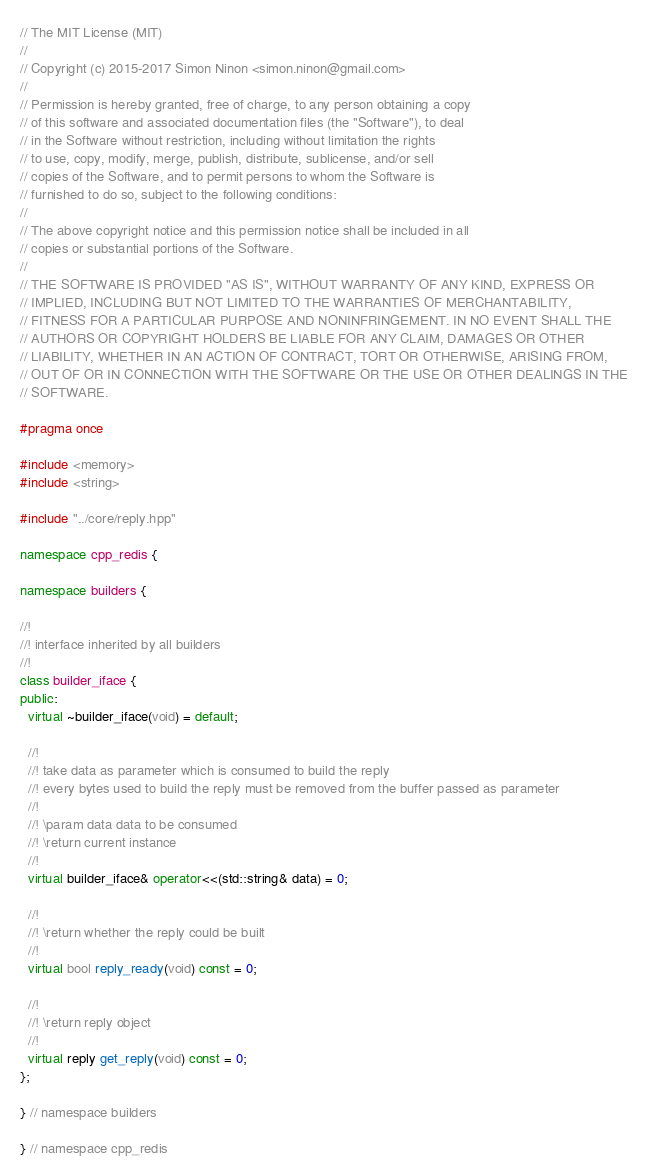Convert code to text. <code><loc_0><loc_0><loc_500><loc_500><_C++_>// The MIT License (MIT)
//
// Copyright (c) 2015-2017 Simon Ninon <simon.ninon@gmail.com>
//
// Permission is hereby granted, free of charge, to any person obtaining a copy
// of this software and associated documentation files (the "Software"), to deal
// in the Software without restriction, including without limitation the rights
// to use, copy, modify, merge, publish, distribute, sublicense, and/or sell
// copies of the Software, and to permit persons to whom the Software is
// furnished to do so, subject to the following conditions:
//
// The above copyright notice and this permission notice shall be included in all
// copies or substantial portions of the Software.
//
// THE SOFTWARE IS PROVIDED "AS IS", WITHOUT WARRANTY OF ANY KIND, EXPRESS OR
// IMPLIED, INCLUDING BUT NOT LIMITED TO THE WARRANTIES OF MERCHANTABILITY,
// FITNESS FOR A PARTICULAR PURPOSE AND NONINFRINGEMENT. IN NO EVENT SHALL THE
// AUTHORS OR COPYRIGHT HOLDERS BE LIABLE FOR ANY CLAIM, DAMAGES OR OTHER
// LIABILITY, WHETHER IN AN ACTION OF CONTRACT, TORT OR OTHERWISE, ARISING FROM,
// OUT OF OR IN CONNECTION WITH THE SOFTWARE OR THE USE OR OTHER DEALINGS IN THE
// SOFTWARE.

#pragma once

#include <memory>
#include <string>

#include "../core/reply.hpp"

namespace cpp_redis {

namespace builders {

//!
//! interface inherited by all builders
//!
class builder_iface {
public:
  virtual ~builder_iface(void) = default;

  //!
  //! take data as parameter which is consumed to build the reply
  //! every bytes used to build the reply must be removed from the buffer passed as parameter
  //!
  //! \param data data to be consumed
  //! \return current instance
  //!
  virtual builder_iface& operator<<(std::string& data) = 0;

  //!
  //! \return whether the reply could be built
  //!
  virtual bool reply_ready(void) const = 0;

  //!
  //! \return reply object
  //!
  virtual reply get_reply(void) const = 0;
};

} // namespace builders

} // namespace cpp_redis
</code> 